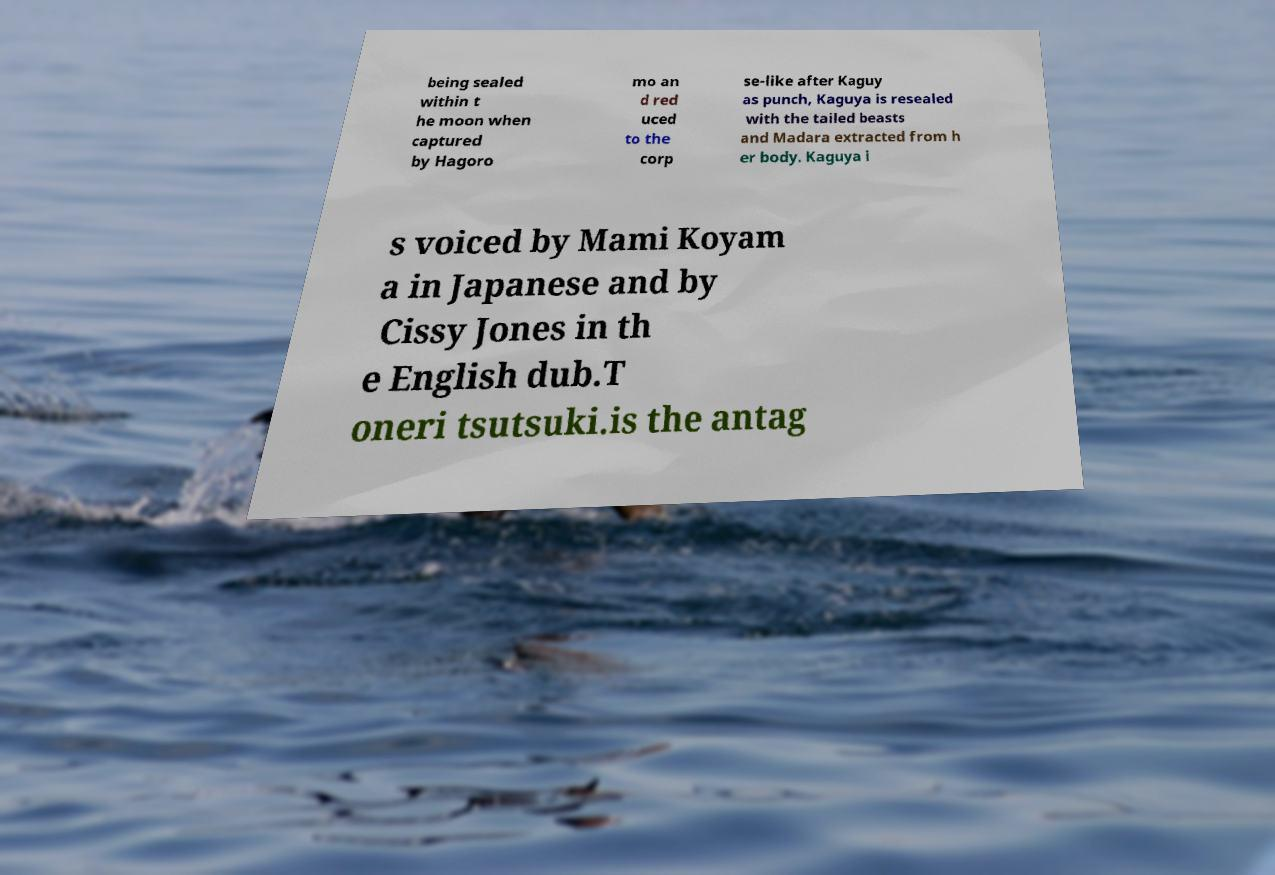I need the written content from this picture converted into text. Can you do that? being sealed within t he moon when captured by Hagoro mo an d red uced to the corp se-like after Kaguy as punch, Kaguya is resealed with the tailed beasts and Madara extracted from h er body. Kaguya i s voiced by Mami Koyam a in Japanese and by Cissy Jones in th e English dub.T oneri tsutsuki.is the antag 